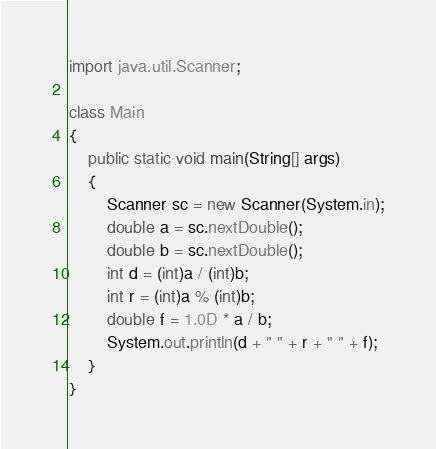Convert code to text. <code><loc_0><loc_0><loc_500><loc_500><_Java_>import java.util.Scanner;

class Main
{
	public static void main(String[] args)
	{
		Scanner sc = new Scanner(System.in);
		double a = sc.nextDouble();
		double b = sc.nextDouble();
		int d = (int)a / (int)b;
		int r = (int)a % (int)b;
		double f = 1.0D * a / b;
		System.out.println(d + " " + r + " " + f);
	}
}</code> 